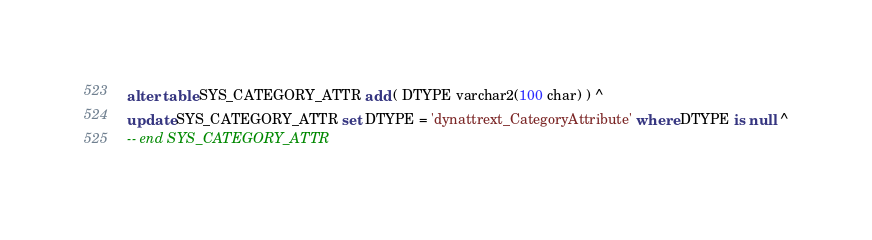<code> <loc_0><loc_0><loc_500><loc_500><_SQL_>alter table SYS_CATEGORY_ATTR add ( DTYPE varchar2(100 char) ) ^
update SYS_CATEGORY_ATTR set DTYPE = 'dynattrext_CategoryAttribute' where DTYPE is null ^
-- end SYS_CATEGORY_ATTR
</code> 